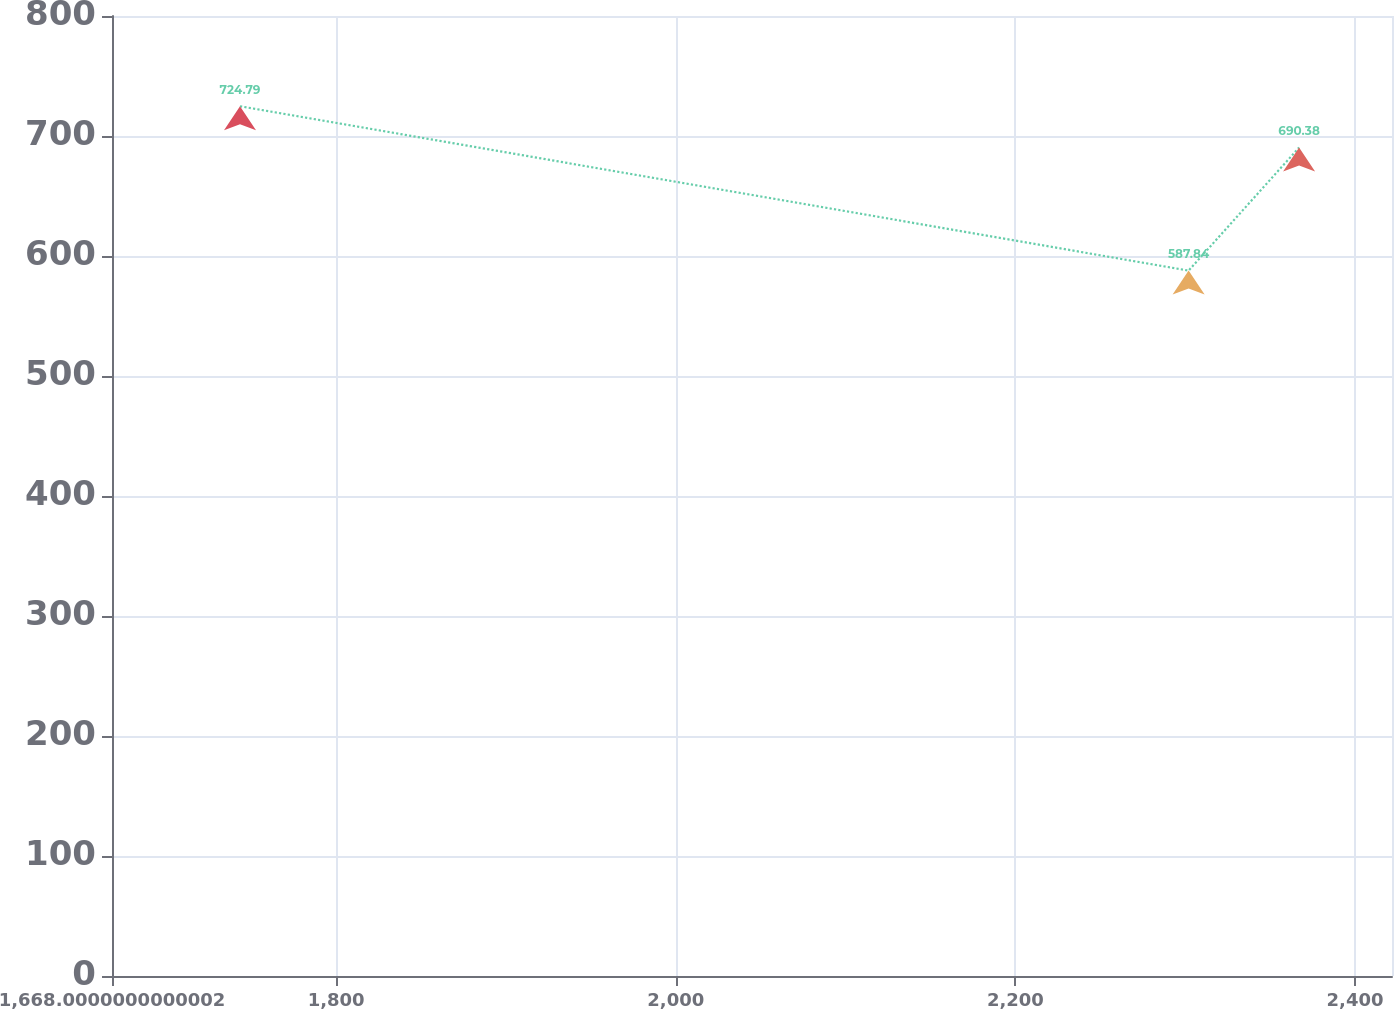Convert chart. <chart><loc_0><loc_0><loc_500><loc_500><line_chart><ecel><fcel>Unnamed: 1<nl><fcel>1743.38<fcel>724.79<nl><fcel>2302.03<fcel>587.84<nl><fcel>2367.08<fcel>690.38<nl><fcel>2432.13<fcel>625.69<nl><fcel>2497.18<fcel>369.4<nl></chart> 